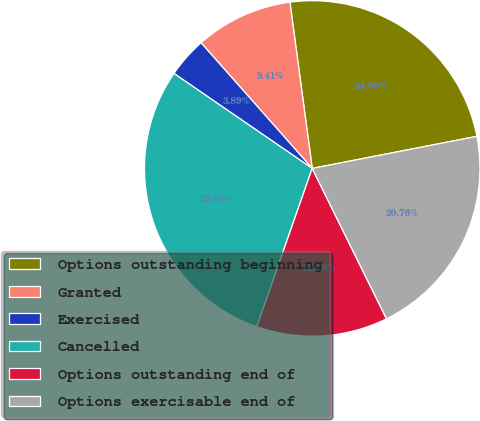Convert chart. <chart><loc_0><loc_0><loc_500><loc_500><pie_chart><fcel>Options outstanding beginning<fcel>Granted<fcel>Exercised<fcel>Cancelled<fcel>Options outstanding end of<fcel>Options exercisable end of<nl><fcel>24.06%<fcel>9.41%<fcel>3.89%<fcel>29.22%<fcel>12.66%<fcel>20.76%<nl></chart> 